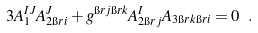Convert formula to latex. <formula><loc_0><loc_0><loc_500><loc_500>3 A _ { 1 } ^ { I J } A _ { 2 \i r { i } } ^ { J } + g ^ { \i r { j } \i r { k } } A _ { 2 \i r { j } } ^ { I } A _ { 3 \i r { k } \i r { i } } = 0 \ .</formula> 